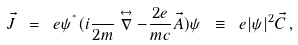<formula> <loc_0><loc_0><loc_500><loc_500>\vec { J } \ = \ e \psi ^ { ^ { * } } ( i \frac { } { 2 m } \stackrel { \leftrightarrow } { \nabla } - \frac { 2 e } { m c } \vec { A } ) \psi \ \equiv \ e | \psi | ^ { 2 } \vec { C } \, ,</formula> 